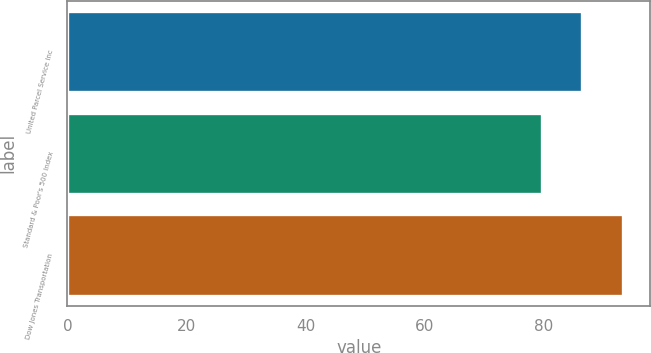Convert chart. <chart><loc_0><loc_0><loc_500><loc_500><bar_chart><fcel>United Parcel Service Inc<fcel>Standard & Poor's 500 Index<fcel>Dow Jones Transportation<nl><fcel>86.42<fcel>79.67<fcel>93.19<nl></chart> 